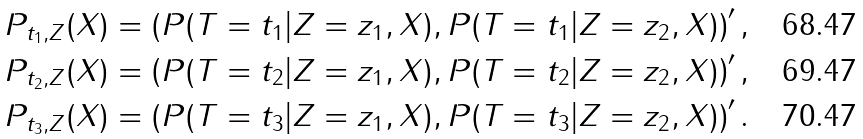Convert formula to latex. <formula><loc_0><loc_0><loc_500><loc_500>P _ { t _ { 1 } , Z } ( X ) & = \left ( P ( T = t _ { 1 } | Z = z _ { 1 } , X ) , P ( T = t _ { 1 } | Z = z _ { 2 } , X ) \right ) ^ { \prime } , \\ P _ { t _ { 2 } , Z } ( X ) & = \left ( P ( T = t _ { 2 } | Z = z _ { 1 } , X ) , P ( T = t _ { 2 } | Z = z _ { 2 } , X ) \right ) ^ { \prime } , \\ P _ { t _ { 3 } , Z } ( X ) & = \left ( P ( T = t _ { 3 } | Z = z _ { 1 } , X ) , P ( T = t _ { 3 } | Z = z _ { 2 } , X ) \right ) ^ { \prime } .</formula> 